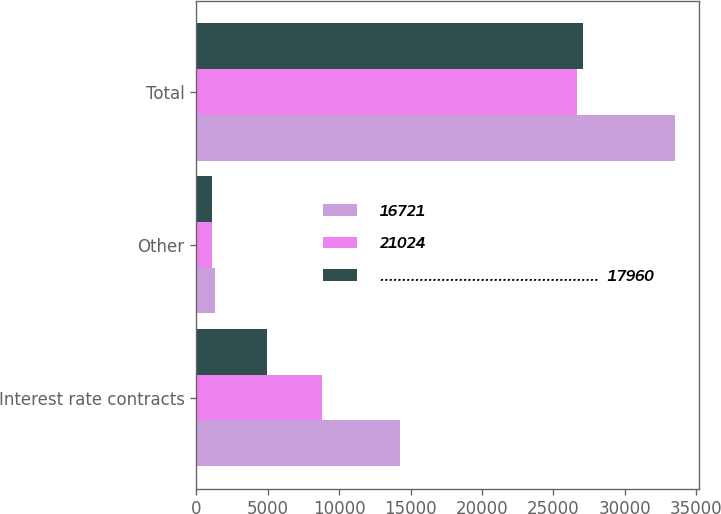Convert chart. <chart><loc_0><loc_0><loc_500><loc_500><stacked_bar_chart><ecel><fcel>Interest rate contracts<fcel>Other<fcel>Total<nl><fcel>16721<fcel>14228<fcel>1340<fcel>33528<nl><fcel>21024<fcel>8812<fcel>1122<fcel>26655<nl><fcel>..................................................  17960<fcel>4947<fcel>1105<fcel>27076<nl></chart> 